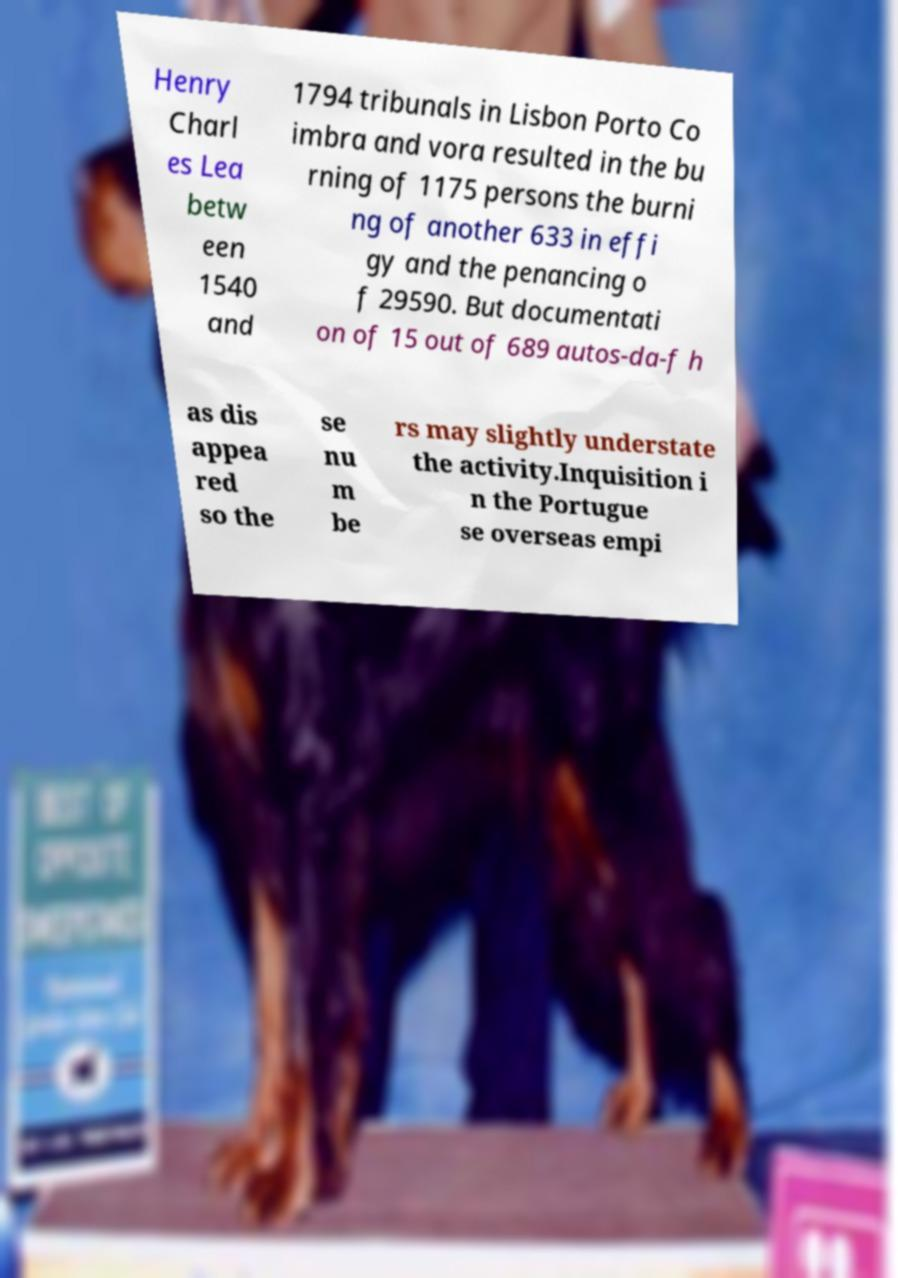I need the written content from this picture converted into text. Can you do that? Henry Charl es Lea betw een 1540 and 1794 tribunals in Lisbon Porto Co imbra and vora resulted in the bu rning of 1175 persons the burni ng of another 633 in effi gy and the penancing o f 29590. But documentati on of 15 out of 689 autos-da-f h as dis appea red so the se nu m be rs may slightly understate the activity.Inquisition i n the Portugue se overseas empi 